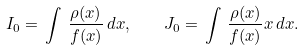<formula> <loc_0><loc_0><loc_500><loc_500>I _ { 0 } = \, \int \, \frac { \rho ( x ) } { f ( x ) } \, d x , \quad J _ { 0 } = \, \int \, \frac { \rho ( x ) } { f ( x ) } x \, d x .</formula> 